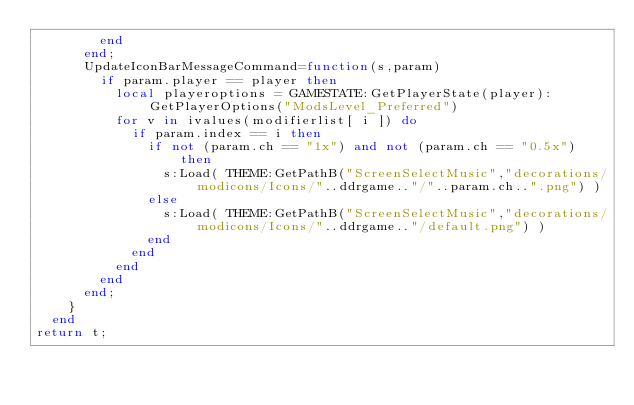Convert code to text. <code><loc_0><loc_0><loc_500><loc_500><_Lua_>				end
			end;
			UpdateIconBarMessageCommand=function(s,param)
				if param.player == player then
					local playeroptions = GAMESTATE:GetPlayerState(player):GetPlayerOptions("ModsLevel_Preferred")
					for v in ivalues(modifierlist[ i ]) do
						if param.index == i then
							if not (param.ch == "1x") and not (param.ch == "0.5x") then
								s:Load( THEME:GetPathB("ScreenSelectMusic","decorations/modicons/Icons/"..ddrgame.."/"..param.ch..".png") )
							else
								s:Load( THEME:GetPathB("ScreenSelectMusic","decorations/modicons/Icons/"..ddrgame.."/default.png") )
							end
						end
					end
				end
			end;
		}
	end
return t;</code> 